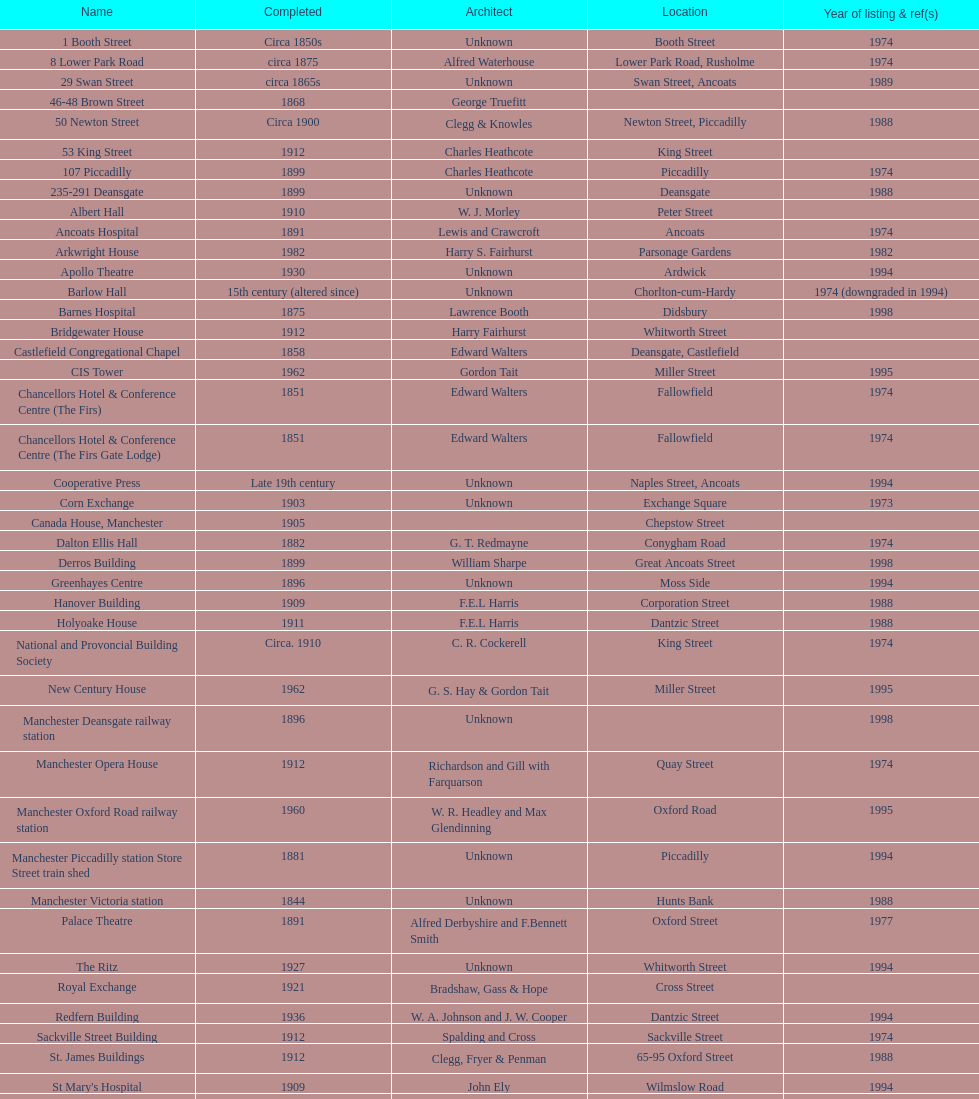Give me the full table as a dictionary. {'header': ['Name', 'Completed', 'Architect', 'Location', 'Year of listing & ref(s)'], 'rows': [['1 Booth Street', 'Circa 1850s', 'Unknown', 'Booth Street', '1974'], ['8 Lower Park Road', 'circa 1875', 'Alfred Waterhouse', 'Lower Park Road, Rusholme', '1974'], ['29 Swan Street', 'circa 1865s', 'Unknown', 'Swan Street, Ancoats', '1989'], ['46-48 Brown Street', '1868', 'George Truefitt', '', ''], ['50 Newton Street', 'Circa 1900', 'Clegg & Knowles', 'Newton Street, Piccadilly', '1988'], ['53 King Street', '1912', 'Charles Heathcote', 'King Street', ''], ['107 Piccadilly', '1899', 'Charles Heathcote', 'Piccadilly', '1974'], ['235-291 Deansgate', '1899', 'Unknown', 'Deansgate', '1988'], ['Albert Hall', '1910', 'W. J. Morley', 'Peter Street', ''], ['Ancoats Hospital', '1891', 'Lewis and Crawcroft', 'Ancoats', '1974'], ['Arkwright House', '1982', 'Harry S. Fairhurst', 'Parsonage Gardens', '1982'], ['Apollo Theatre', '1930', 'Unknown', 'Ardwick', '1994'], ['Barlow Hall', '15th century (altered since)', 'Unknown', 'Chorlton-cum-Hardy', '1974 (downgraded in 1994)'], ['Barnes Hospital', '1875', 'Lawrence Booth', 'Didsbury', '1998'], ['Bridgewater House', '1912', 'Harry Fairhurst', 'Whitworth Street', ''], ['Castlefield Congregational Chapel', '1858', 'Edward Walters', 'Deansgate, Castlefield', ''], ['CIS Tower', '1962', 'Gordon Tait', 'Miller Street', '1995'], ['Chancellors Hotel & Conference Centre (The Firs)', '1851', 'Edward Walters', 'Fallowfield', '1974'], ['Chancellors Hotel & Conference Centre (The Firs Gate Lodge)', '1851', 'Edward Walters', 'Fallowfield', '1974'], ['Cooperative Press', 'Late 19th century', 'Unknown', 'Naples Street, Ancoats', '1994'], ['Corn Exchange', '1903', 'Unknown', 'Exchange Square', '1973'], ['Canada House, Manchester', '1905', '', 'Chepstow Street', ''], ['Dalton Ellis Hall', '1882', 'G. T. Redmayne', 'Conygham Road', '1974'], ['Derros Building', '1899', 'William Sharpe', 'Great Ancoats Street', '1998'], ['Greenhayes Centre', '1896', 'Unknown', 'Moss Side', '1994'], ['Hanover Building', '1909', 'F.E.L Harris', 'Corporation Street', '1988'], ['Holyoake House', '1911', 'F.E.L Harris', 'Dantzic Street', '1988'], ['National and Provoncial Building Society', 'Circa. 1910', 'C. R. Cockerell', 'King Street', '1974'], ['New Century House', '1962', 'G. S. Hay & Gordon Tait', 'Miller Street', '1995'], ['Manchester Deansgate railway station', '1896', 'Unknown', '', '1998'], ['Manchester Opera House', '1912', 'Richardson and Gill with Farquarson', 'Quay Street', '1974'], ['Manchester Oxford Road railway station', '1960', 'W. R. Headley and Max Glendinning', 'Oxford Road', '1995'], ['Manchester Piccadilly station Store Street train shed', '1881', 'Unknown', 'Piccadilly', '1994'], ['Manchester Victoria station', '1844', 'Unknown', 'Hunts Bank', '1988'], ['Palace Theatre', '1891', 'Alfred Derbyshire and F.Bennett Smith', 'Oxford Street', '1977'], ['The Ritz', '1927', 'Unknown', 'Whitworth Street', '1994'], ['Royal Exchange', '1921', 'Bradshaw, Gass & Hope', 'Cross Street', ''], ['Redfern Building', '1936', 'W. A. Johnson and J. W. Cooper', 'Dantzic Street', '1994'], ['Sackville Street Building', '1912', 'Spalding and Cross', 'Sackville Street', '1974'], ['St. James Buildings', '1912', 'Clegg, Fryer & Penman', '65-95 Oxford Street', '1988'], ["St Mary's Hospital", '1909', 'John Ely', 'Wilmslow Road', '1994'], ['Samuel Alexander Building', '1919', 'Percy Scott Worthington', 'Oxford Road', '2010'], ['Ship Canal House', '1927', 'Harry S. Fairhurst', 'King Street', '1982'], ['Smithfield Market Hall', '1857', 'Unknown', 'Swan Street, Ancoats', '1973'], ['Strangeways Gaol Gatehouse', '1868', 'Alfred Waterhouse', 'Sherborne Street', '1974'], ['Strangeways Prison ventilation and watch tower', '1868', 'Alfred Waterhouse', 'Sherborne Street', '1974'], ['Theatre Royal', '1845', 'Irwin and Chester', 'Peter Street', '1974'], ['Toast Rack', '1960', 'L. C. Howitt', 'Fallowfield', '1999'], ['The Old Wellington Inn', 'Mid-16th century', 'Unknown', 'Shambles Square', '1952'], ['Whitworth Park Mansions', 'Circa 1840s', 'Unknown', 'Whitworth Park', '1974']]} What is the road of the sole structure mentioned in 1989? Swan Street. 